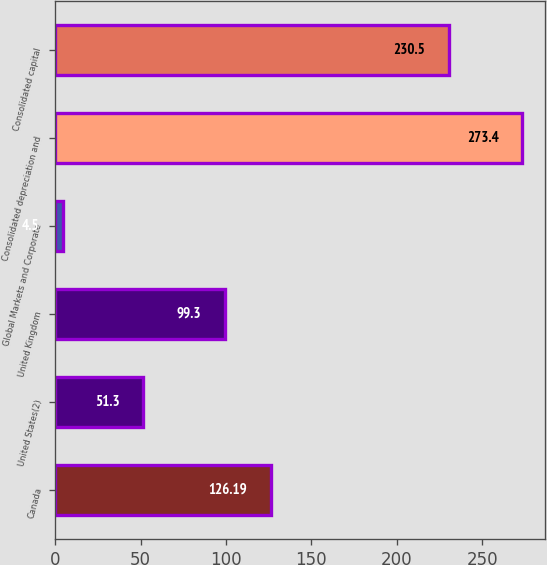Convert chart. <chart><loc_0><loc_0><loc_500><loc_500><bar_chart><fcel>Canada<fcel>United States(2)<fcel>United Kingdom<fcel>Global Markets and Corporate<fcel>Consolidated depreciation and<fcel>Consolidated capital<nl><fcel>126.19<fcel>51.3<fcel>99.3<fcel>4.5<fcel>273.4<fcel>230.5<nl></chart> 